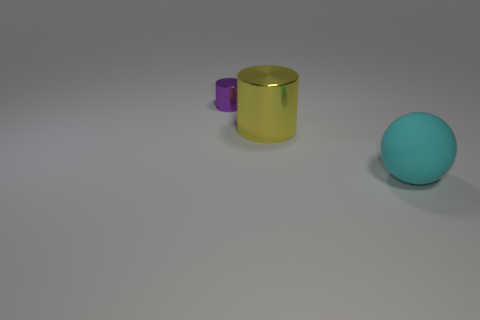Add 2 purple matte things. How many objects exist? 5 Subtract all balls. How many objects are left? 2 Subtract 1 balls. How many balls are left? 0 Add 2 small shiny things. How many small shiny things exist? 3 Subtract 0 yellow spheres. How many objects are left? 3 Subtract all yellow cylinders. Subtract all purple cubes. How many cylinders are left? 1 Subtract all purple balls. How many purple cylinders are left? 1 Subtract all large yellow shiny cylinders. Subtract all large cylinders. How many objects are left? 1 Add 3 cylinders. How many cylinders are left? 5 